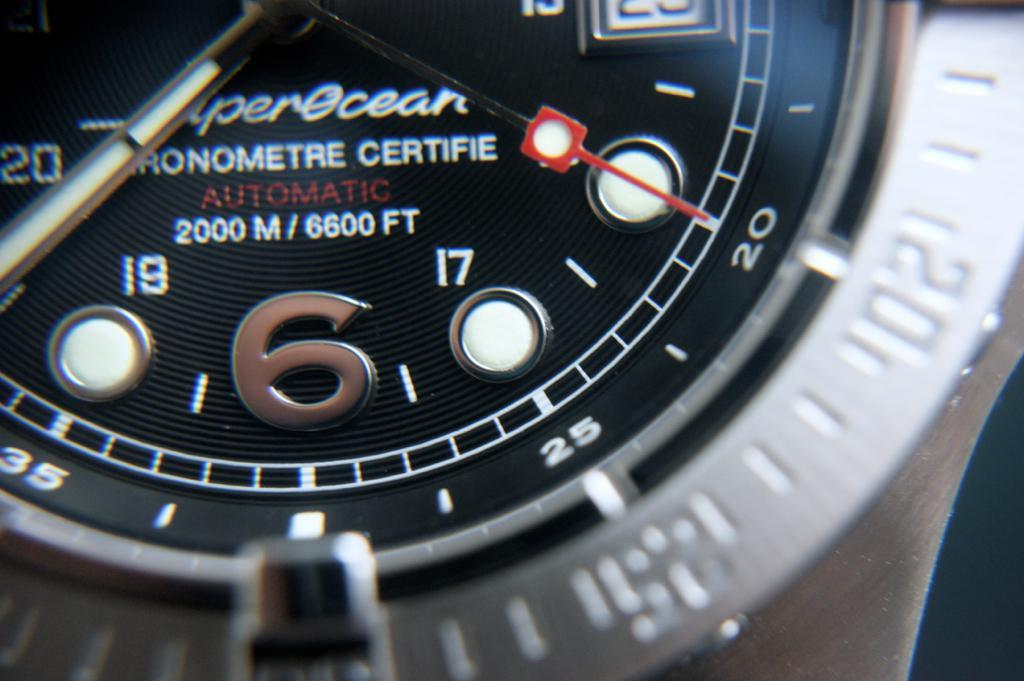<image>
Relay a brief, clear account of the picture shown. A black and silver wrist watch with the word automatic written in red on the center. 